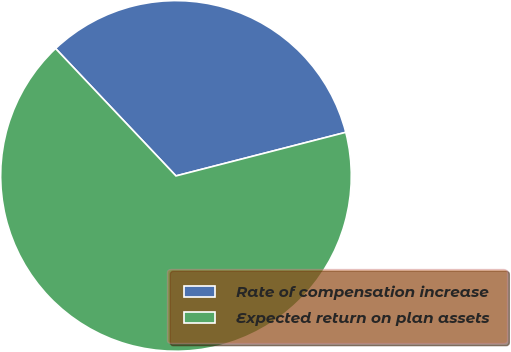Convert chart to OTSL. <chart><loc_0><loc_0><loc_500><loc_500><pie_chart><fcel>Rate of compensation increase<fcel>Expected return on plan assets<nl><fcel>33.05%<fcel>66.95%<nl></chart> 